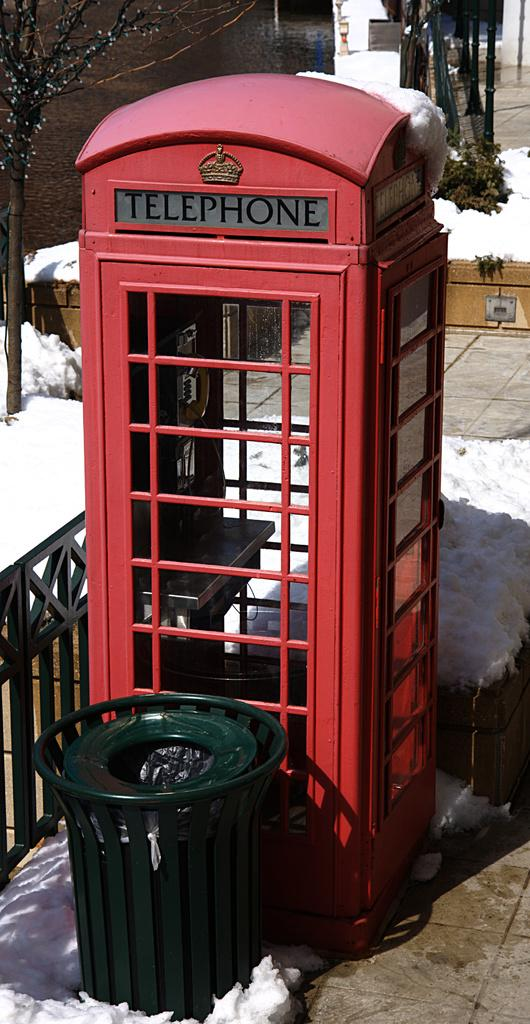<image>
Write a terse but informative summary of the picture. Next to a green, outdoor garbage can is a red, old fashioned phone booth that says Telephone at the top. 